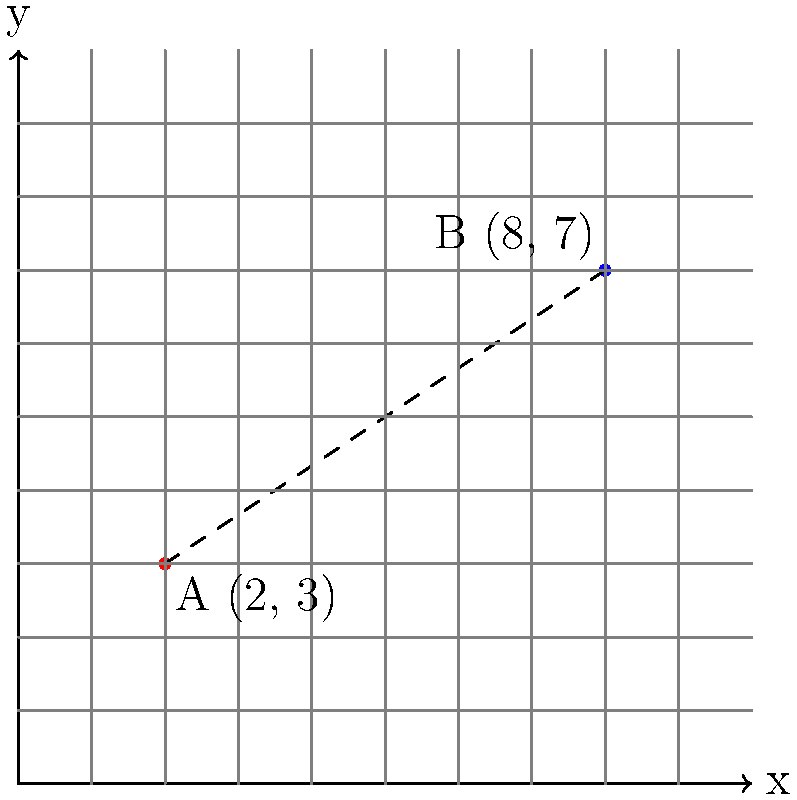As a business owner, you're evaluating the impact of new zoning laws on your company's expansion plans. You have two potential locations for new branches, represented by points A and B on the graph. Point A (2, 3) represents your current main office, while point B (8, 7) represents a proposed new location. Calculate the straight-line distance between these two points to determine if the expansion falls within the new zoning restrictions, which limit new branches to be no more than 7 units away from the main office. To solve this problem, we'll use the distance formula derived from the Pythagorean theorem:

1) The distance formula is: 
   $$d = \sqrt{(x_2 - x_1)^2 + (y_2 - y_1)^2}$$

2) We have:
   Point A: $(x_1, y_1) = (2, 3)$
   Point B: $(x_2, y_2) = (8, 7)$

3) Let's substitute these values into the formula:
   $$d = \sqrt{(8 - 2)^2 + (7 - 3)^2}$$

4) Simplify inside the parentheses:
   $$d = \sqrt{6^2 + 4^2}$$

5) Calculate the squares:
   $$d = \sqrt{36 + 16}$$

6) Add inside the square root:
   $$d = \sqrt{52}$$

7) Simplify the square root:
   $$d = 2\sqrt{13} \approx 7.21$$

The distance between points A and B is approximately 7.21 units.
Answer: $2\sqrt{13}$ units or approximately 7.21 units 